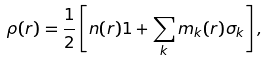Convert formula to latex. <formula><loc_0><loc_0><loc_500><loc_500>\rho ( r ) = \frac { 1 } { 2 } \left [ n ( r ) 1 + \sum _ { k } m _ { k } ( r ) \sigma _ { k } \right ] ,</formula> 